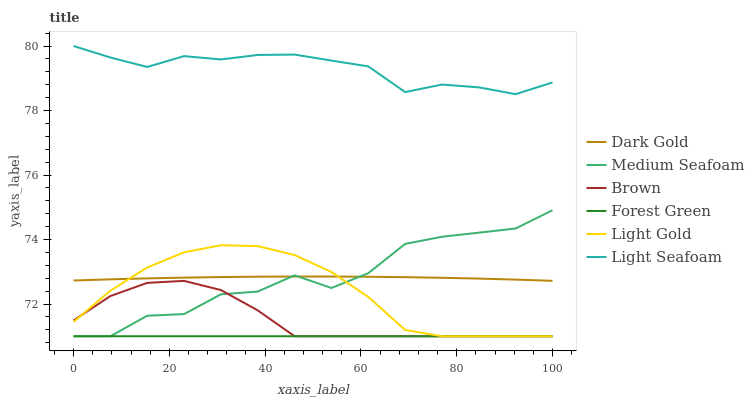Does Forest Green have the minimum area under the curve?
Answer yes or no. Yes. Does Light Seafoam have the maximum area under the curve?
Answer yes or no. Yes. Does Dark Gold have the minimum area under the curve?
Answer yes or no. No. Does Dark Gold have the maximum area under the curve?
Answer yes or no. No. Is Forest Green the smoothest?
Answer yes or no. Yes. Is Medium Seafoam the roughest?
Answer yes or no. Yes. Is Dark Gold the smoothest?
Answer yes or no. No. Is Dark Gold the roughest?
Answer yes or no. No. Does Brown have the lowest value?
Answer yes or no. Yes. Does Dark Gold have the lowest value?
Answer yes or no. No. Does Light Seafoam have the highest value?
Answer yes or no. Yes. Does Dark Gold have the highest value?
Answer yes or no. No. Is Forest Green less than Dark Gold?
Answer yes or no. Yes. Is Dark Gold greater than Forest Green?
Answer yes or no. Yes. Does Dark Gold intersect Light Gold?
Answer yes or no. Yes. Is Dark Gold less than Light Gold?
Answer yes or no. No. Is Dark Gold greater than Light Gold?
Answer yes or no. No. Does Forest Green intersect Dark Gold?
Answer yes or no. No. 